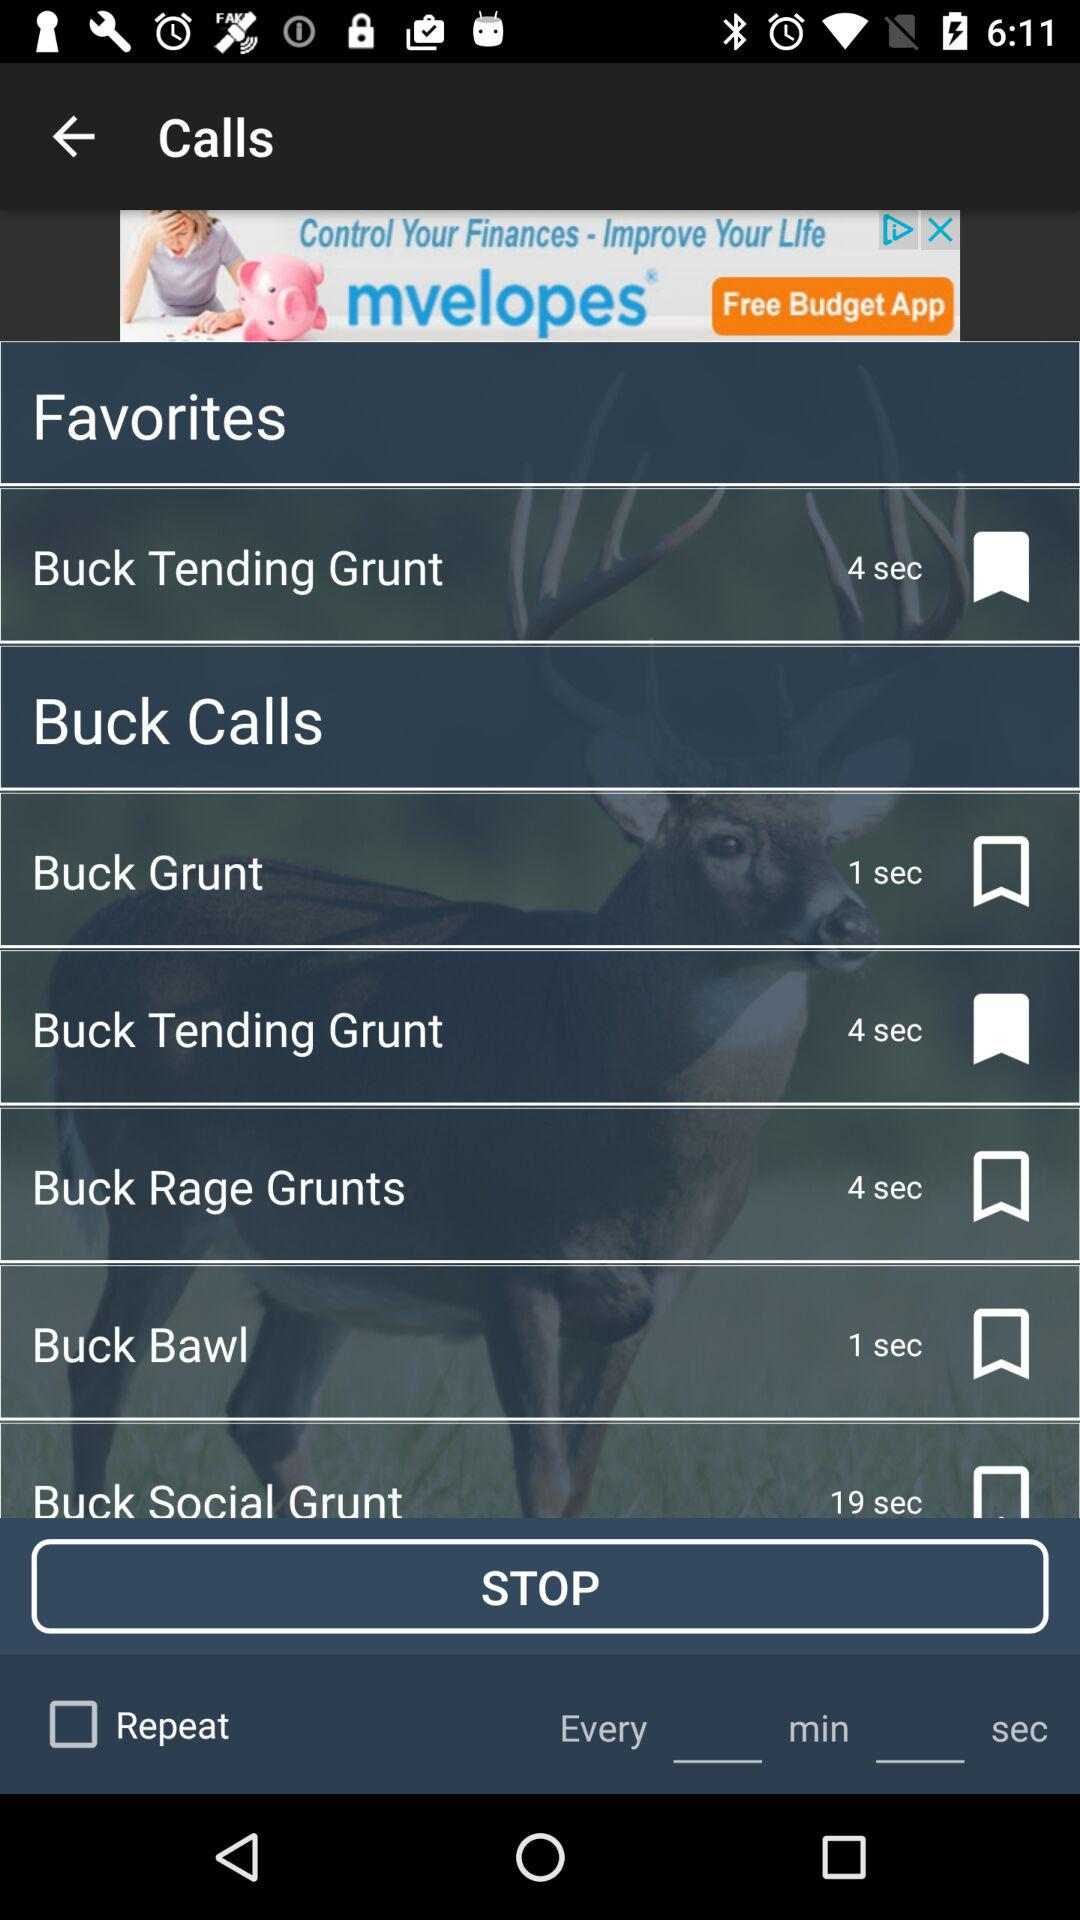Which calls are bookmarked? The call that is bookmarked is "Buck Tending Grunt". 